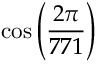<formula> <loc_0><loc_0><loc_500><loc_500>\cos \left ( { \frac { 2 \pi } { 7 7 1 } } \right )</formula> 